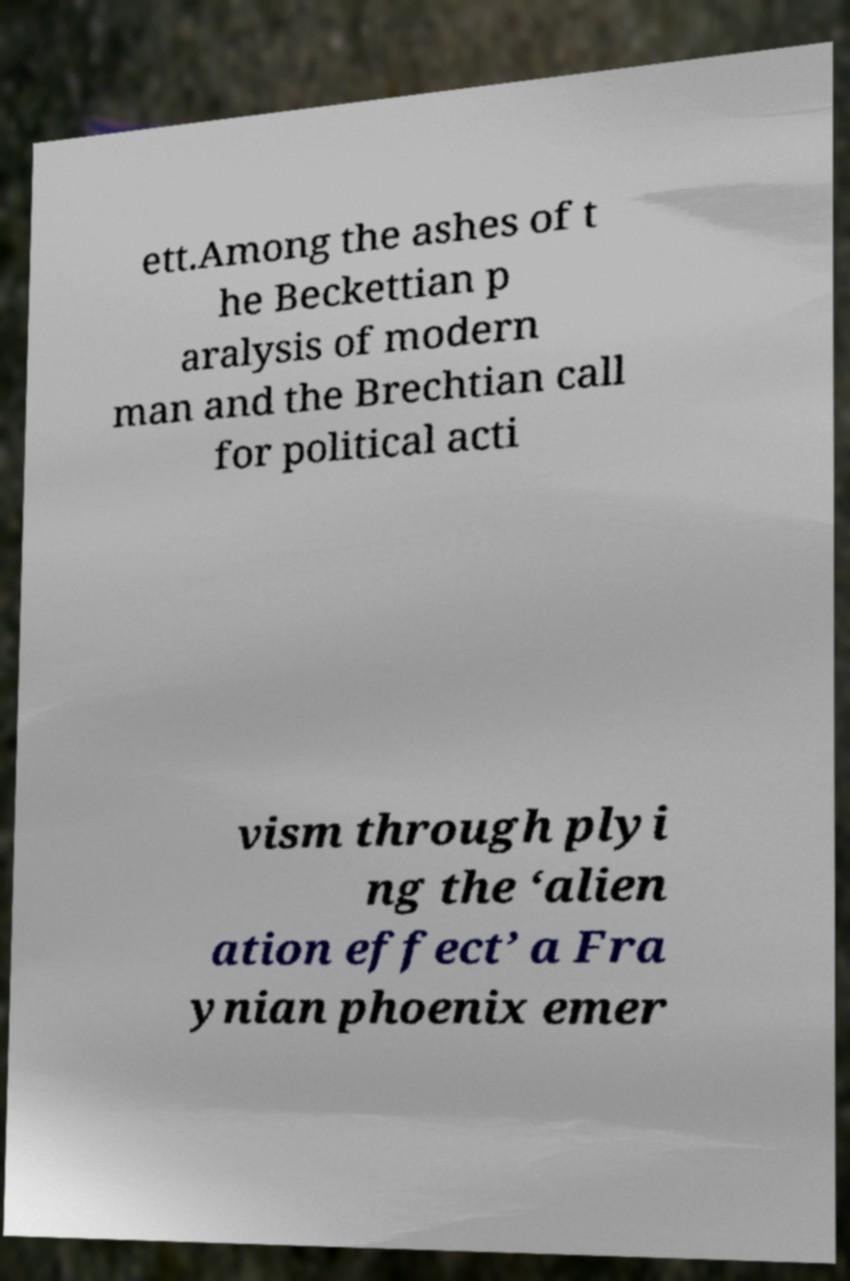Could you assist in decoding the text presented in this image and type it out clearly? ett.Among the ashes of t he Beckettian p aralysis of modern man and the Brechtian call for political acti vism through plyi ng the ‘alien ation effect’ a Fra ynian phoenix emer 